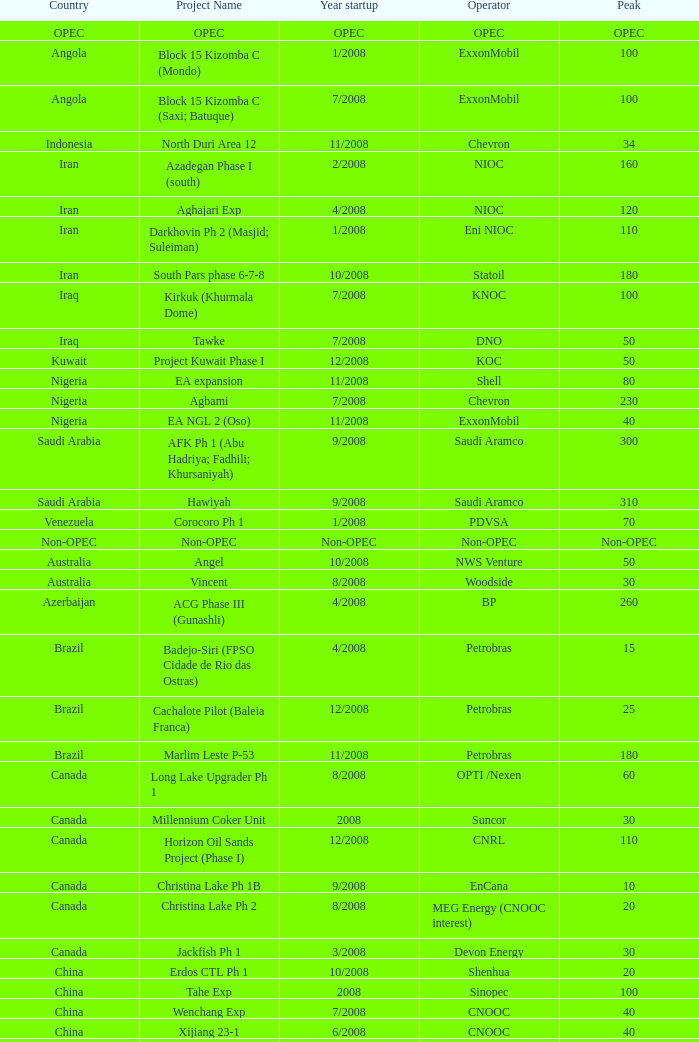What is the Operator with a Peak that is 55? PEMEX. 